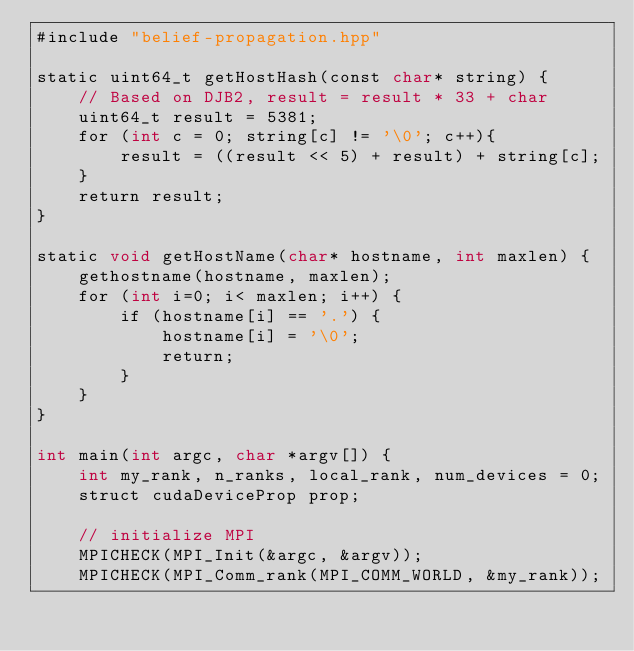<code> <loc_0><loc_0><loc_500><loc_500><_Cuda_>#include "belief-propagation.hpp"

static uint64_t getHostHash(const char* string) {
    // Based on DJB2, result = result * 33 + char
    uint64_t result = 5381;
    for (int c = 0; string[c] != '\0'; c++){
        result = ((result << 5) + result) + string[c];
    }
    return result;
}

static void getHostName(char* hostname, int maxlen) {
    gethostname(hostname, maxlen);
    for (int i=0; i< maxlen; i++) {
        if (hostname[i] == '.') {
            hostname[i] = '\0';
            return;
        }
    }
}

int main(int argc, char *argv[]) {
    int my_rank, n_ranks, local_rank, num_devices = 0;
    struct cudaDeviceProp prop;

    // initialize MPI
    MPICHECK(MPI_Init(&argc, &argv));
    MPICHECK(MPI_Comm_rank(MPI_COMM_WORLD, &my_rank));</code> 